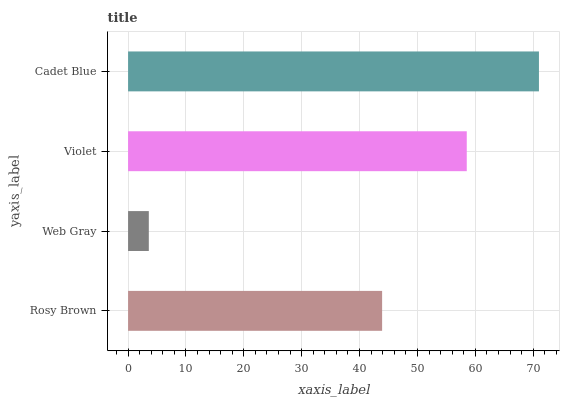Is Web Gray the minimum?
Answer yes or no. Yes. Is Cadet Blue the maximum?
Answer yes or no. Yes. Is Violet the minimum?
Answer yes or no. No. Is Violet the maximum?
Answer yes or no. No. Is Violet greater than Web Gray?
Answer yes or no. Yes. Is Web Gray less than Violet?
Answer yes or no. Yes. Is Web Gray greater than Violet?
Answer yes or no. No. Is Violet less than Web Gray?
Answer yes or no. No. Is Violet the high median?
Answer yes or no. Yes. Is Rosy Brown the low median?
Answer yes or no. Yes. Is Web Gray the high median?
Answer yes or no. No. Is Web Gray the low median?
Answer yes or no. No. 